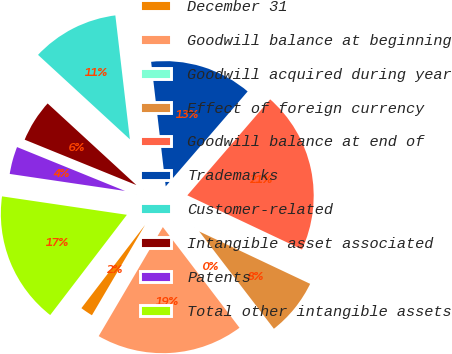Convert chart to OTSL. <chart><loc_0><loc_0><loc_500><loc_500><pie_chart><fcel>December 31<fcel>Goodwill balance at beginning<fcel>Goodwill acquired during year<fcel>Effect of foreign currency<fcel>Goodwill balance at end of<fcel>Trademarks<fcel>Customer-related<fcel>Intangible asset associated<fcel>Patents<fcel>Total other intangible assets<nl><fcel>1.93%<fcel>18.82%<fcel>0.06%<fcel>7.56%<fcel>20.69%<fcel>13.19%<fcel>11.31%<fcel>5.69%<fcel>3.81%<fcel>16.94%<nl></chart> 